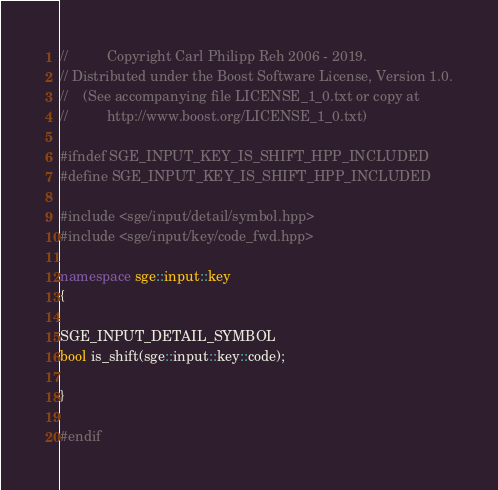Convert code to text. <code><loc_0><loc_0><loc_500><loc_500><_C++_>//          Copyright Carl Philipp Reh 2006 - 2019.
// Distributed under the Boost Software License, Version 1.0.
//    (See accompanying file LICENSE_1_0.txt or copy at
//          http://www.boost.org/LICENSE_1_0.txt)

#ifndef SGE_INPUT_KEY_IS_SHIFT_HPP_INCLUDED
#define SGE_INPUT_KEY_IS_SHIFT_HPP_INCLUDED

#include <sge/input/detail/symbol.hpp>
#include <sge/input/key/code_fwd.hpp>

namespace sge::input::key
{

SGE_INPUT_DETAIL_SYMBOL
bool is_shift(sge::input::key::code);

}

#endif
</code> 